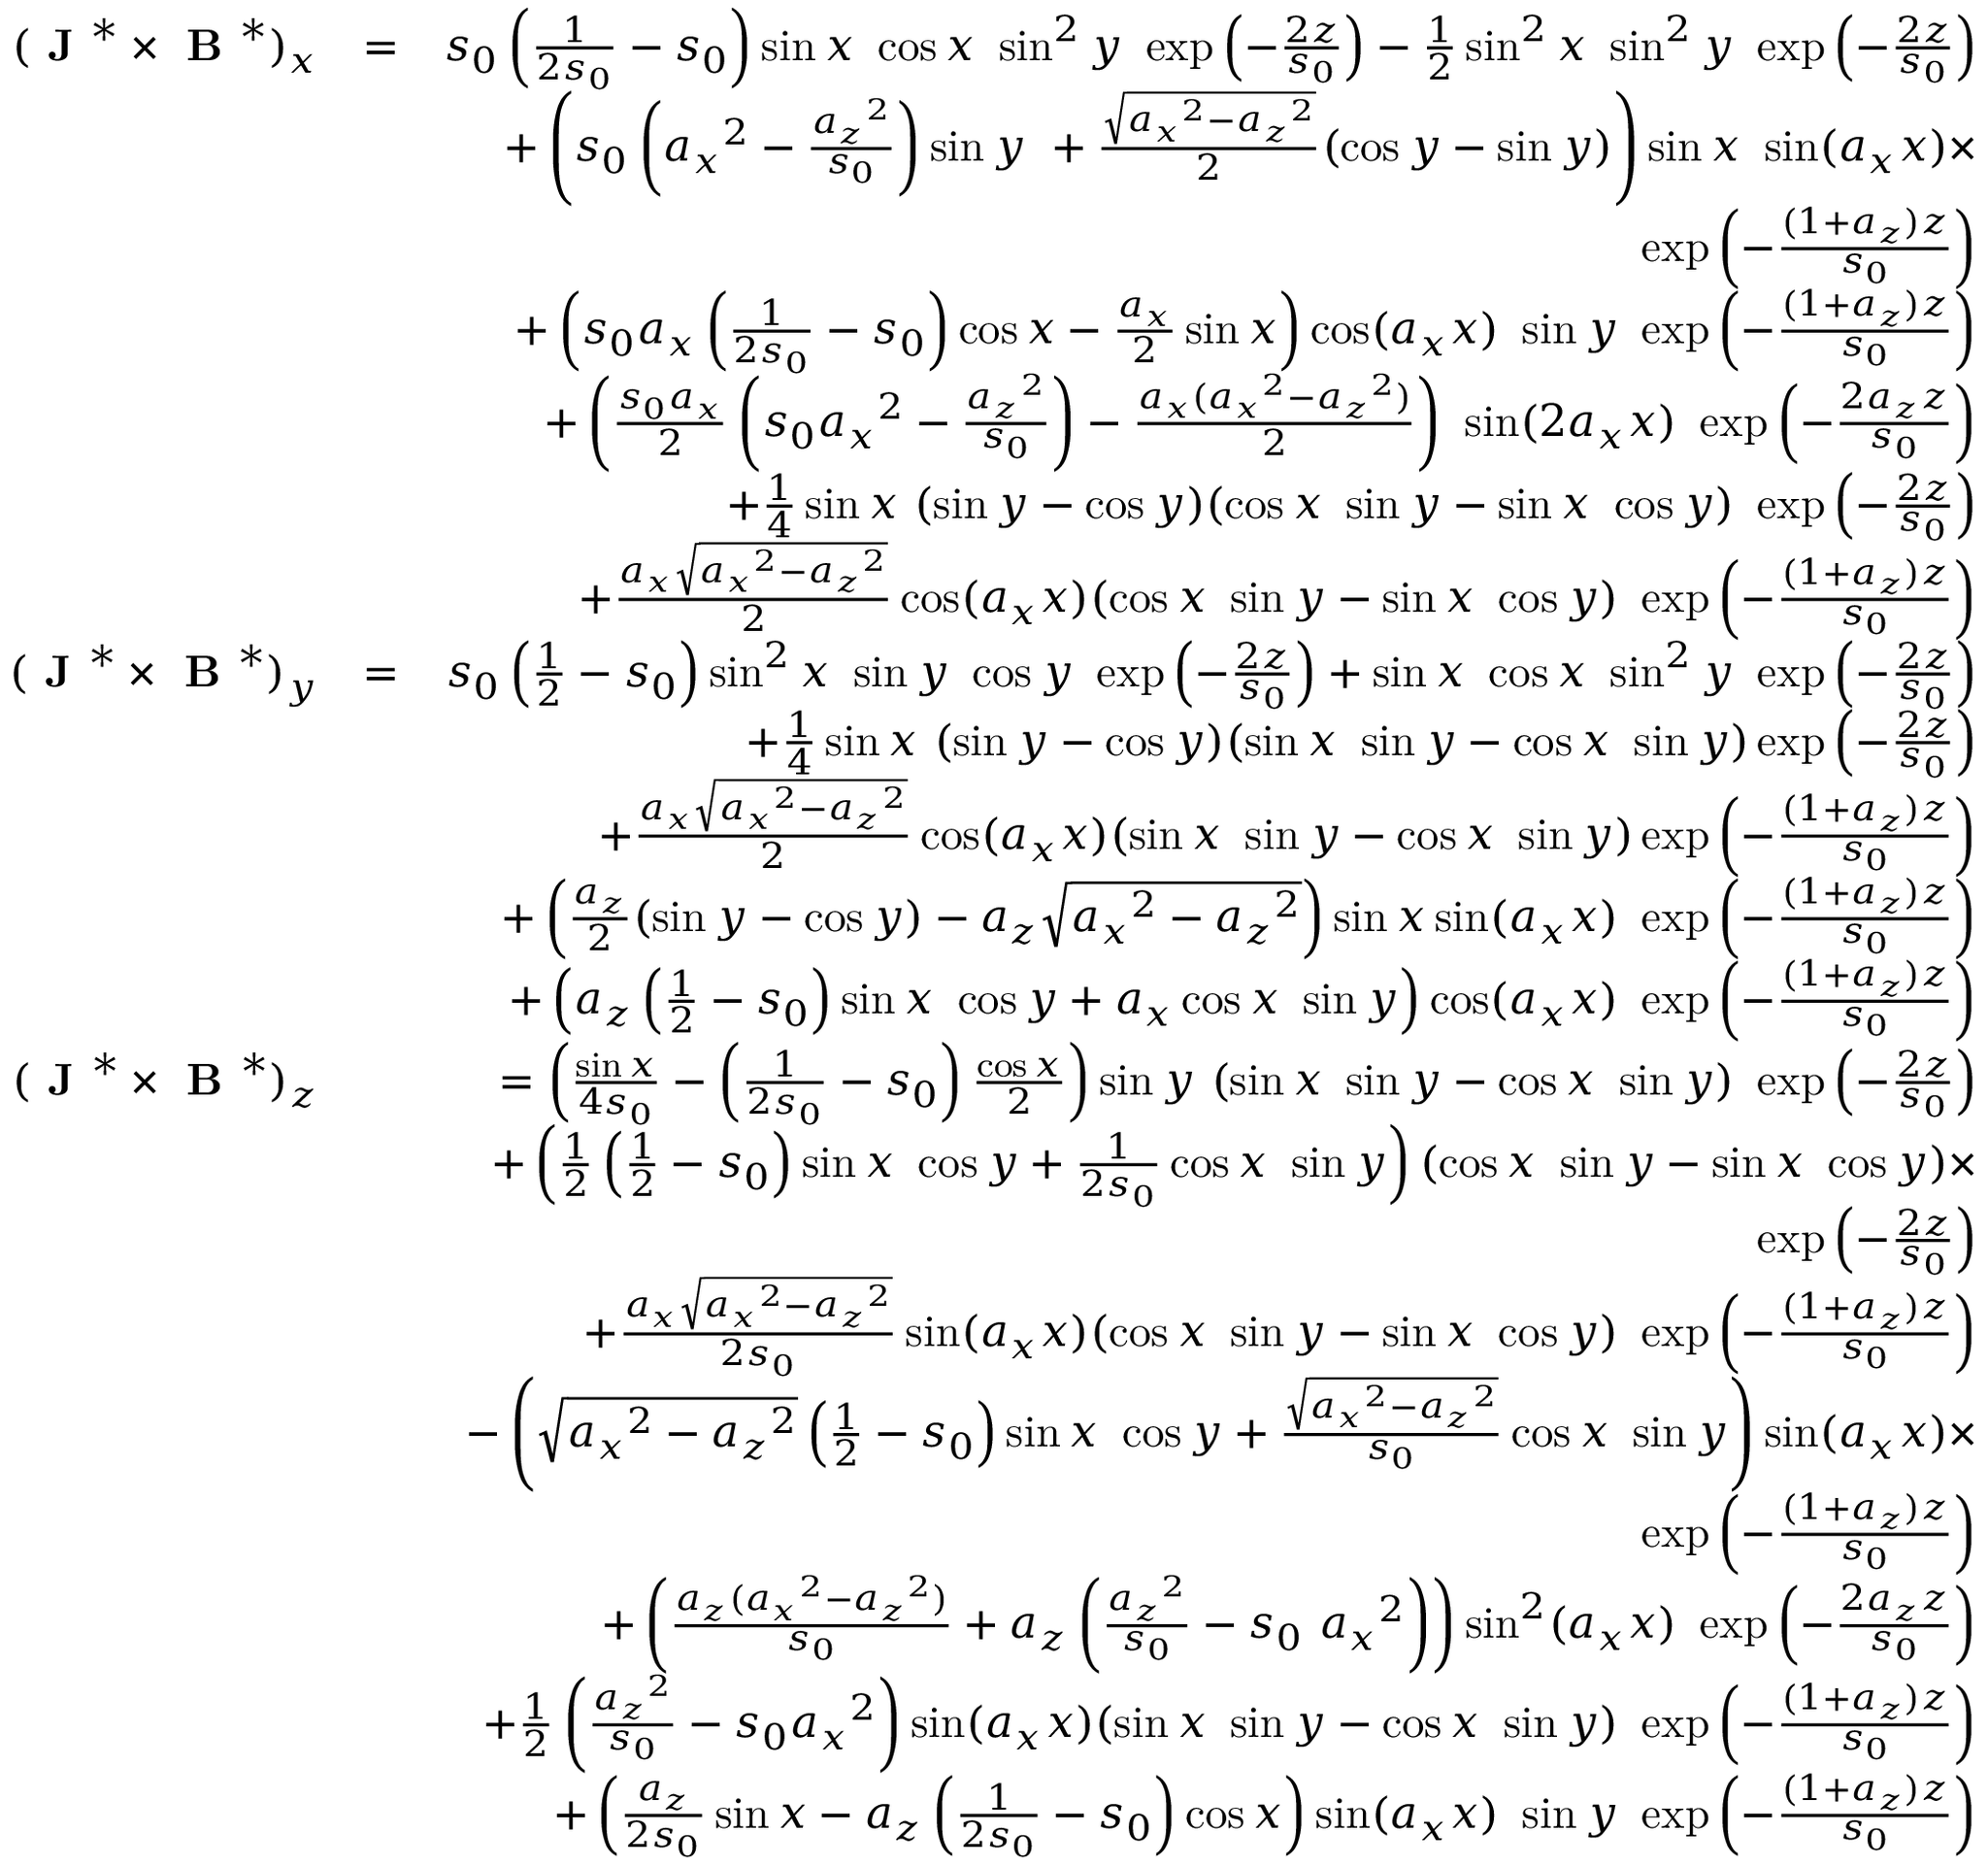<formula> <loc_0><loc_0><loc_500><loc_500>\begin{array} { r l r } { ( J ^ { * } \times B ^ { * } ) _ { x } } & { = } & { s _ { 0 } \left ( \frac { 1 } { 2 s _ { 0 } } - s _ { 0 } \right ) \sin x \cos x \sin ^ { 2 } y \exp \left ( - \frac { 2 z } { s _ { 0 } } \right ) - \frac { 1 } { 2 } \sin ^ { 2 } x \sin ^ { 2 } y \exp \left ( - \frac { 2 z } { s _ { 0 } } \right ) } \\ & { + \left ( s _ { 0 } \left ( { a _ { x } } ^ { 2 } - \frac { { a _ { z } } ^ { 2 } } { s _ { 0 } } \right ) \sin y + \frac { \sqrt { { a _ { x } } ^ { 2 } - { a _ { z } } ^ { 2 } } } { 2 } ( \cos y - \sin y ) \right ) \sin x \sin ( a _ { x } x ) \times } \\ & { \exp \left ( - \frac { ( 1 + a _ { z } ) z } { s _ { 0 } } \right ) } \\ & { + \left ( s _ { 0 } a _ { x } \left ( \frac { 1 } { 2 s _ { 0 } } - s _ { 0 } \right ) \cos x - \frac { a _ { x } } { 2 } \sin x \right ) \cos ( a _ { x } x ) \sin y \exp \left ( - \frac { ( 1 + a _ { z } ) z } { s _ { 0 } } \right ) } \\ & { + \left ( \frac { s _ { 0 } a _ { x } } { 2 } \left ( s _ { 0 } { a _ { x } } ^ { 2 } - \frac { { a _ { z } } ^ { 2 } } { s _ { 0 } } \right ) - \frac { a _ { x } ( { a _ { x } } ^ { 2 } - { a _ { z } } ^ { 2 } ) } { 2 } \right ) \sin ( 2 a _ { x } x ) \exp \left ( - \frac { 2 a _ { z } z } { s _ { 0 } } \right ) } \\ & { + \frac { 1 } { 4 } \sin x ( \sin y - \cos y ) ( \cos x \sin y - \sin x \cos y ) \exp \left ( - \frac { 2 z } { s _ { 0 } } \right ) } \\ & { + \frac { a _ { x } \sqrt { { a _ { x } } ^ { 2 } - { a _ { z } } ^ { 2 } } } { 2 } \cos ( a _ { x } x ) ( \cos x \sin y - \sin x \cos y ) \exp \left ( - \frac { ( 1 + a _ { z } ) z } { s _ { 0 } } \right ) } \\ { ( J ^ { * } \times B ^ { * } ) _ { y } } & { = } & { s _ { 0 } \left ( \frac { 1 } { 2 } - s _ { 0 } \right ) \sin ^ { 2 } x \sin y \cos y \exp \left ( - \frac { 2 z } { s _ { 0 } } \right ) + \sin x \cos x \sin ^ { 2 } y \exp \left ( - \frac { 2 z } { s _ { 0 } } \right ) } \\ & { + \frac { 1 } { 4 } \sin x ( \sin y - \cos y ) ( \sin x \sin y - \cos x \sin y ) \exp \left ( - \frac { 2 z } { s _ { 0 } } \right ) } \\ & { + \frac { a _ { x } \sqrt { { a _ { x } } ^ { 2 } - { a _ { z } } ^ { 2 } } } { 2 } \cos ( a _ { x } x ) ( \sin x \sin y - \cos x \sin y ) \exp \left ( - \frac { ( 1 + a _ { z } ) z } { s _ { 0 } } \right ) } \\ & { + \left ( \frac { a _ { z } } { 2 } ( \sin y - \cos y ) - a _ { z } \sqrt { { a _ { x } } ^ { 2 } - { a _ { z } } ^ { 2 } } \right ) \sin x \sin ( a _ { x } x ) \exp \left ( - \frac { ( 1 + a _ { z } ) z } { s _ { 0 } } \right ) } \\ & { + \left ( a _ { z } \left ( \frac { 1 } { 2 } - s _ { 0 } \right ) \sin x \cos y + a _ { x } \cos x \sin y \right ) \cos ( a _ { x } x ) \exp \left ( - \frac { ( 1 + a _ { z } ) z } { s _ { 0 } } \right ) } \\ { ( J ^ { * } \times B ^ { * } ) _ { z } } & { = \left ( \frac { \sin x } { 4 s _ { 0 } } - \left ( \frac { 1 } { 2 s _ { 0 } } - s _ { 0 } \right ) \frac { \cos x } { 2 } \right ) \sin y ( \sin x \sin y - \cos x \sin y ) \exp \left ( - \frac { 2 z } { s _ { 0 } } \right ) } \\ & { + \left ( \frac { 1 } { 2 } \left ( \frac { 1 } { 2 } - s _ { 0 } \right ) \sin x \cos y + \frac { 1 } { 2 s _ { 0 } } \cos x \sin y \right ) ( \cos x \sin y - \sin x \cos y ) \times } \\ & { \exp \left ( - \frac { 2 z } { s _ { 0 } } \right ) } \\ & { + \frac { a _ { x } \sqrt { { a _ { x } } ^ { 2 } - { a _ { z } } ^ { 2 } } } { 2 s _ { 0 } } \sin ( a _ { x } x ) ( \cos x \sin y - \sin x \cos y ) \exp \left ( - \frac { ( 1 + a _ { z } ) z } { s _ { 0 } } \right ) } \\ & { - \left ( \sqrt { { a _ { x } } ^ { 2 } - { a _ { z } } ^ { 2 } } \left ( \frac { 1 } { 2 } - s _ { 0 } \right ) \sin x \cos y + \frac { \sqrt { { a _ { x } } ^ { 2 } - { a _ { z } } ^ { 2 } } } { s _ { 0 } } \cos x \sin y \right ) \sin ( a _ { x } x ) \times } \\ & { \exp \left ( - \frac { ( 1 + a _ { z } ) z } { s _ { 0 } } \right ) } \\ & { + \left ( \frac { a _ { z } ( { a _ { x } } ^ { 2 } - { a _ { z } } ^ { 2 } ) } { s _ { 0 } } + a _ { z } \left ( \frac { { a _ { z } } ^ { 2 } } { s _ { 0 } } - s _ { 0 } { a _ { x } } ^ { 2 } \right ) \right ) \sin ^ { 2 } ( a _ { x } x ) \exp \left ( - \frac { 2 a _ { z } z } { s _ { 0 } } \right ) } \\ & { + \frac { 1 } { 2 } \left ( \frac { { a _ { z } } ^ { 2 } } { s _ { 0 } } - s _ { 0 } { a _ { x } } ^ { 2 } \right ) \sin ( a _ { x } x ) ( \sin x \sin y - \cos x \sin y ) \exp \left ( - \frac { ( 1 + a _ { z } ) z } { s _ { 0 } } \right ) } \\ & { + \left ( \frac { a _ { z } } { 2 s _ { 0 } } \sin x - a _ { z } \left ( \frac { 1 } { 2 s _ { 0 } } - s _ { 0 } \right ) \cos x \right ) \sin ( a _ { x } x ) \sin y \exp \left ( - \frac { ( 1 + a _ { z } ) z } { s _ { 0 } } \right ) } \end{array}</formula> 